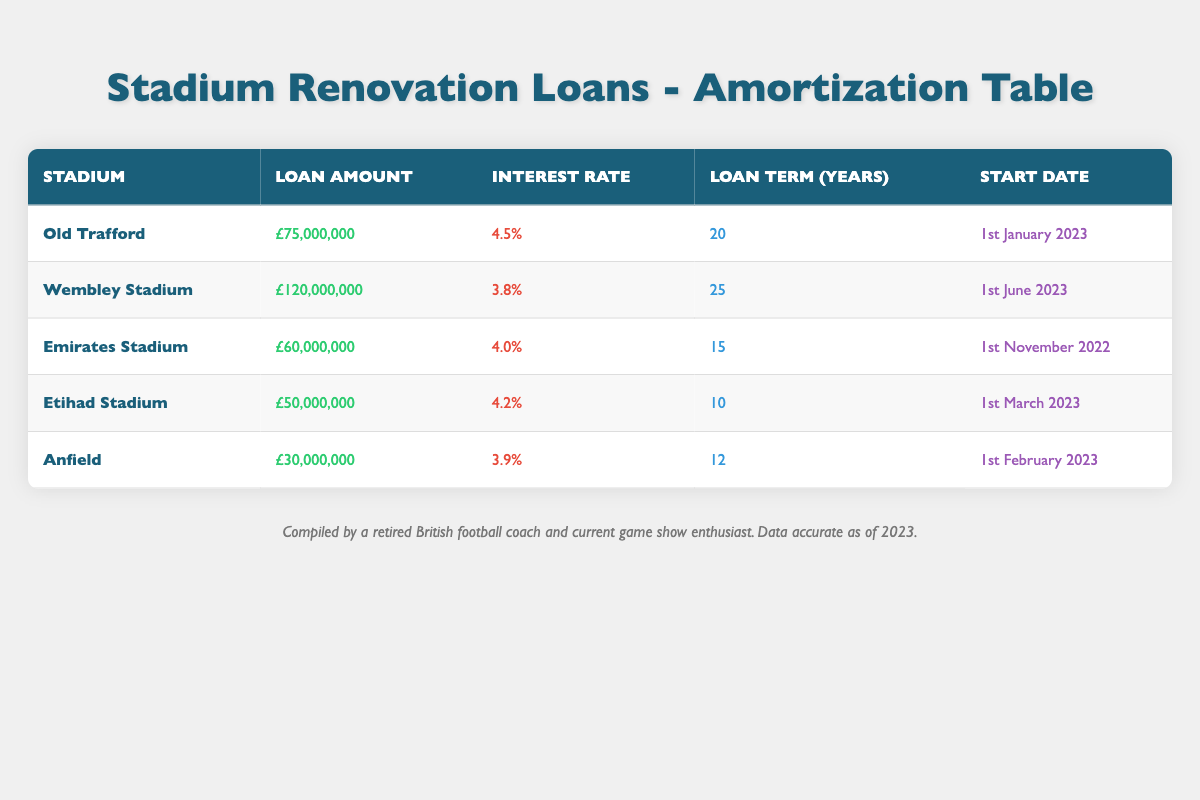What is the loan amount for Wembley Stadium? The table clearly states the loan amount for Wembley Stadium under the respective column, which is £120,000,000.
Answer: £120,000,000 How long is the loan term for Old Trafford? From the table, the loan term for Old Trafford can be found in the corresponding column, and it is 20 years.
Answer: 20 years Which stadium has the highest interest rate? By comparing all interest rates listed in the table, Wembley Stadium has the highest interest rate at 3.8%.
Answer: Wembley Stadium What is the total loan amount for Emirates Stadium and Anfield combined? To find the total loan amount for both Emirates Stadium (£60,000,000) and Anfield (£30,000,000), we add these figures: 60,000,000 + 30,000,000 = 90,000,000.
Answer: £90,000,000 Is the loan term for Etihad Stadium less than that of Anfield? The loan term for Etihad Stadium is 10 years, while Anfield's loan term is 12 years. Since 10 is less than 12, the statement is true.
Answer: Yes What is the average interest rate among all five stadium loans? The interest rates are 4.5%, 3.8%, 4.0%, 4.2%, and 3.9%. First, we convert these percentages to decimals: 0.045, 0.038, 0.040, 0.042, and 0.039. Next, we sum them: 0.045 + 0.038 + 0.040 + 0.042 + 0.039 = 0.204. Finally, we divide by 5 to find the average: 0.204 / 5 = 0.0408, or 4.08%.
Answer: 4.08% Which stadium started its loan the earliest? By examining the start dates in the table, Old Trafford has the earliest start date of 1st January 2023.
Answer: Old Trafford Is the loan amount for Anfield greater than the loan amount for Etihad Stadium? The loan amount for Anfield is £30,000,000 and for Etihad Stadium it is £50,000,000. As £30,000,000 is less than £50,000,000, the statement is false.
Answer: No If you subtract the loan amount of Old Trafford from Wembley Stadium, what is the difference? The loan amount for Wembley Stadium is £120,000,000 and for Old Trafford is £75,000,000. The difference is calculated as 120,000,000 - 75,000,000 = 45,000,000.
Answer: £45,000,000 